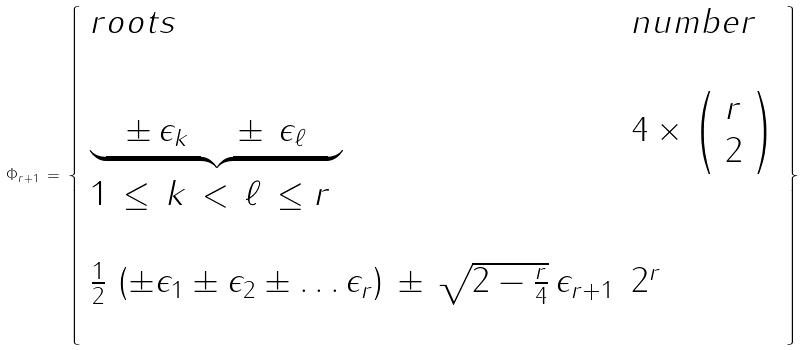<formula> <loc_0><loc_0><loc_500><loc_500>\Phi _ { r + 1 } \, = \, \left \{ \begin{array} { l l } { r o o t s } & { n u m b e r } \\ { \null } & { \null } \\ { { { \underbrace { \quad \pm \, \epsilon _ { k } \, \quad \pm \, \epsilon _ { \ell } \quad } } } } & { { 4 \times \left ( \begin{array} { l } { r } \\ { 2 } \end{array} \right ) } } \\ { 1 \, \leq \, k \, < \, \ell \, \leq r } & { \null } \\ { \null } & { \null } \\ { { { \frac { 1 } { 2 } \, \left ( \pm \epsilon _ { 1 } \pm \epsilon _ { 2 } \pm \dots \epsilon _ { r } \right ) \, \pm \, \sqrt { 2 - \frac { r } { 4 } } \, \epsilon _ { r + 1 } } } } & { { 2 ^ { r } } } \\ { \null } & { \null } \end{array} \right \}</formula> 